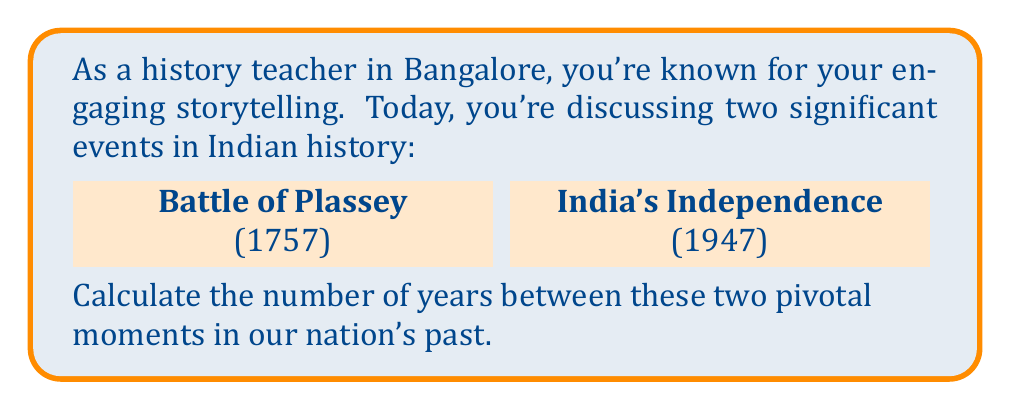Can you solve this math problem? Let's approach this step-by-step:

1) First, we need to identify the years of the two events:
   - Battle of Plassey: 1757
   - India's Independence: 1947

2) To find the number of years between these events, we subtract the earlier year from the later year:

   $$1947 - 1757 = 190$$

3) We can verify this result by breaking it down:
   - From 1757 to 1800 is 43 years
   - From 1800 to 1900 is 100 years
   - From 1900 to 1947 is 47 years

   $$43 + 100 + 47 = 190$$

4) Therefore, the time between the Battle of Plassey and India's Independence is 190 years.

This calculation helps us grasp the span of British influence in India, from its effective beginning with the East India Company's victory at Plassey to the end of the British Raj.
Answer: 190 years 